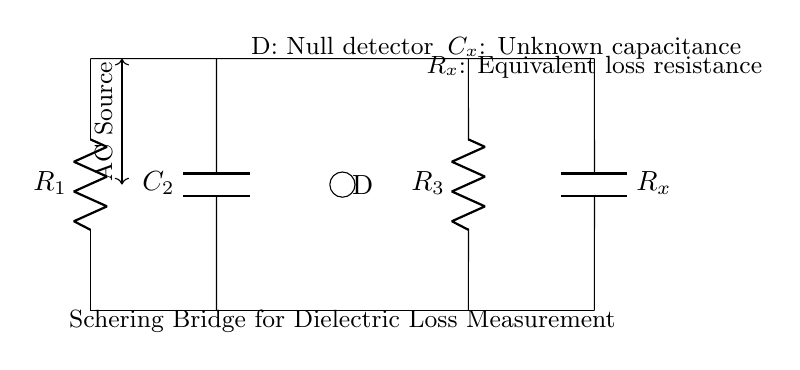What is the function of the device labeled D? The device labeled D in the circuit diagram is a null detector, which is used to indicate the balance condition of the bridge. When the bridge is balanced, it will show no current or voltage difference, which the null detector will indicate.
Answer: null detector What are the two capacitors in the circuit called? The two capacitors in the circuit are called C2 and Cx. C2 is a known capacitor, while Cx is the unknown capacitance whose dielectric loss is being measured.
Answer: C2 and Cx What are the components labeled R1 and R3? R1 and R3 are resistors in the Schering bridge. R1 is connected to one side of the bridge, while R3 is connected to the other side, contributing to the balance condition required for measuring dielectric loss.
Answer: resistors How many resistors are present in the circuit? There are three resistors in the circuit labeled R1, R3, and the equivalent loss resistance Rx, which is represented alongside Cx.
Answer: three What does the AC source provide to the circuit? The AC source provides alternating current to the circuit, necessary for establishing the conditions required to operate the Schering bridge accurately for dielectric loss measurement.
Answer: alternating current What is the role of the component labeled Rx? The component labeled Rx is the equivalent loss resistance associated with the unknown capacitance Cx. It indicates the energy loss in the dielectric material being tested, which is a crucial factor in assessing insulation quality.
Answer: equivalent loss resistance 